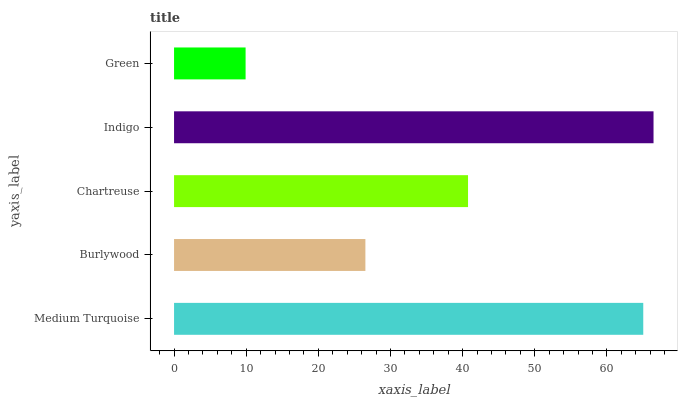Is Green the minimum?
Answer yes or no. Yes. Is Indigo the maximum?
Answer yes or no. Yes. Is Burlywood the minimum?
Answer yes or no. No. Is Burlywood the maximum?
Answer yes or no. No. Is Medium Turquoise greater than Burlywood?
Answer yes or no. Yes. Is Burlywood less than Medium Turquoise?
Answer yes or no. Yes. Is Burlywood greater than Medium Turquoise?
Answer yes or no. No. Is Medium Turquoise less than Burlywood?
Answer yes or no. No. Is Chartreuse the high median?
Answer yes or no. Yes. Is Chartreuse the low median?
Answer yes or no. Yes. Is Indigo the high median?
Answer yes or no. No. Is Medium Turquoise the low median?
Answer yes or no. No. 